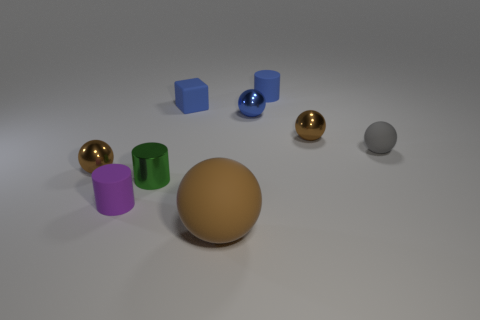Subtract all brown spheres. How many spheres are left? 2 Subtract all gray cubes. How many brown spheres are left? 3 Add 1 cylinders. How many objects exist? 10 Subtract all blue balls. How many balls are left? 4 Subtract all cylinders. How many objects are left? 6 Subtract 1 cubes. How many cubes are left? 0 Subtract 1 blue cylinders. How many objects are left? 8 Subtract all brown balls. Subtract all blue cylinders. How many balls are left? 2 Subtract all cubes. Subtract all small brown metal spheres. How many objects are left? 6 Add 5 gray rubber spheres. How many gray rubber spheres are left? 6 